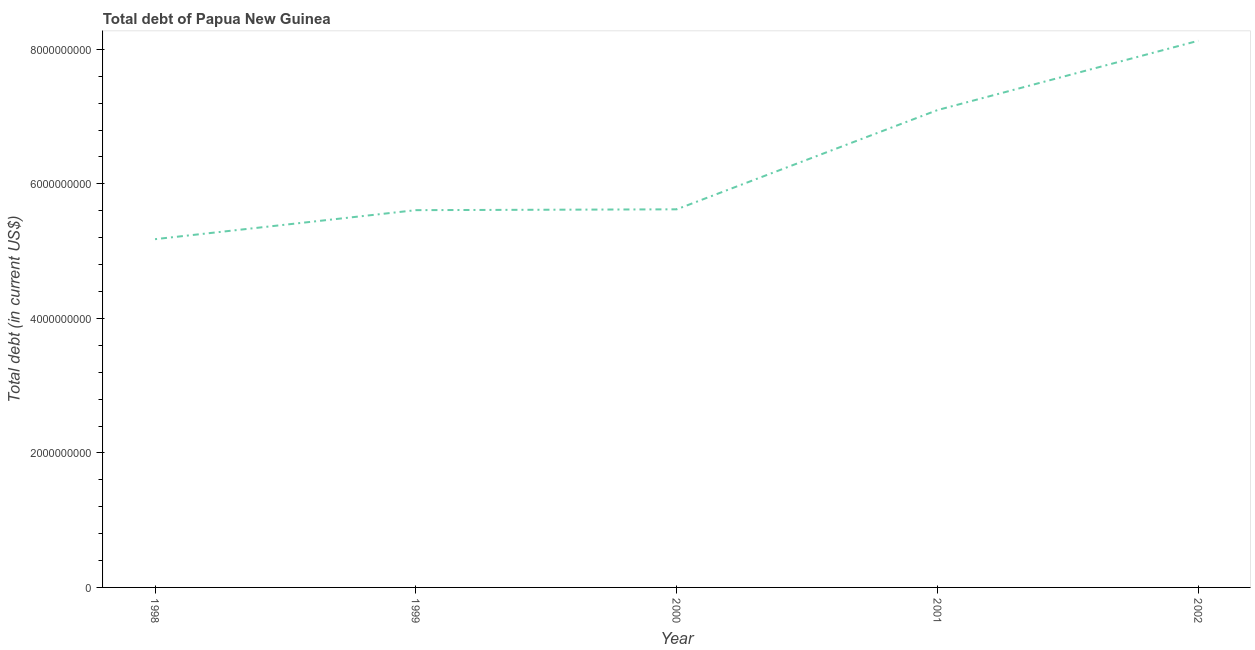What is the total debt in 1998?
Your answer should be very brief. 5.18e+09. Across all years, what is the maximum total debt?
Offer a very short reply. 8.13e+09. Across all years, what is the minimum total debt?
Provide a short and direct response. 5.18e+09. In which year was the total debt maximum?
Your response must be concise. 2002. What is the sum of the total debt?
Your answer should be very brief. 3.16e+1. What is the difference between the total debt in 1998 and 1999?
Make the answer very short. -4.32e+08. What is the average total debt per year?
Provide a succinct answer. 6.33e+09. What is the median total debt?
Keep it short and to the point. 5.62e+09. In how many years, is the total debt greater than 1200000000 US$?
Give a very brief answer. 5. What is the ratio of the total debt in 1999 to that in 2000?
Your answer should be compact. 1. Is the total debt in 2000 less than that in 2002?
Offer a terse response. Yes. Is the difference between the total debt in 2000 and 2001 greater than the difference between any two years?
Provide a succinct answer. No. What is the difference between the highest and the second highest total debt?
Make the answer very short. 1.03e+09. What is the difference between the highest and the lowest total debt?
Your answer should be very brief. 2.95e+09. How many lines are there?
Keep it short and to the point. 1. How many years are there in the graph?
Offer a terse response. 5. Does the graph contain any zero values?
Make the answer very short. No. Does the graph contain grids?
Offer a very short reply. No. What is the title of the graph?
Make the answer very short. Total debt of Papua New Guinea. What is the label or title of the X-axis?
Provide a short and direct response. Year. What is the label or title of the Y-axis?
Keep it short and to the point. Total debt (in current US$). What is the Total debt (in current US$) in 1998?
Give a very brief answer. 5.18e+09. What is the Total debt (in current US$) in 1999?
Give a very brief answer. 5.61e+09. What is the Total debt (in current US$) in 2000?
Make the answer very short. 5.62e+09. What is the Total debt (in current US$) of 2001?
Your answer should be very brief. 7.10e+09. What is the Total debt (in current US$) of 2002?
Offer a very short reply. 8.13e+09. What is the difference between the Total debt (in current US$) in 1998 and 1999?
Your answer should be compact. -4.32e+08. What is the difference between the Total debt (in current US$) in 1998 and 2000?
Provide a short and direct response. -4.44e+08. What is the difference between the Total debt (in current US$) in 1998 and 2001?
Provide a short and direct response. -1.92e+09. What is the difference between the Total debt (in current US$) in 1998 and 2002?
Your response must be concise. -2.95e+09. What is the difference between the Total debt (in current US$) in 1999 and 2000?
Ensure brevity in your answer.  -1.24e+07. What is the difference between the Total debt (in current US$) in 1999 and 2001?
Provide a succinct answer. -1.49e+09. What is the difference between the Total debt (in current US$) in 1999 and 2002?
Give a very brief answer. -2.52e+09. What is the difference between the Total debt (in current US$) in 2000 and 2001?
Give a very brief answer. -1.48e+09. What is the difference between the Total debt (in current US$) in 2000 and 2002?
Give a very brief answer. -2.51e+09. What is the difference between the Total debt (in current US$) in 2001 and 2002?
Provide a short and direct response. -1.03e+09. What is the ratio of the Total debt (in current US$) in 1998 to that in 1999?
Provide a succinct answer. 0.92. What is the ratio of the Total debt (in current US$) in 1998 to that in 2000?
Provide a short and direct response. 0.92. What is the ratio of the Total debt (in current US$) in 1998 to that in 2001?
Your response must be concise. 0.73. What is the ratio of the Total debt (in current US$) in 1998 to that in 2002?
Provide a short and direct response. 0.64. What is the ratio of the Total debt (in current US$) in 1999 to that in 2000?
Keep it short and to the point. 1. What is the ratio of the Total debt (in current US$) in 1999 to that in 2001?
Your answer should be very brief. 0.79. What is the ratio of the Total debt (in current US$) in 1999 to that in 2002?
Offer a very short reply. 0.69. What is the ratio of the Total debt (in current US$) in 2000 to that in 2001?
Give a very brief answer. 0.79. What is the ratio of the Total debt (in current US$) in 2000 to that in 2002?
Offer a very short reply. 0.69. What is the ratio of the Total debt (in current US$) in 2001 to that in 2002?
Give a very brief answer. 0.87. 